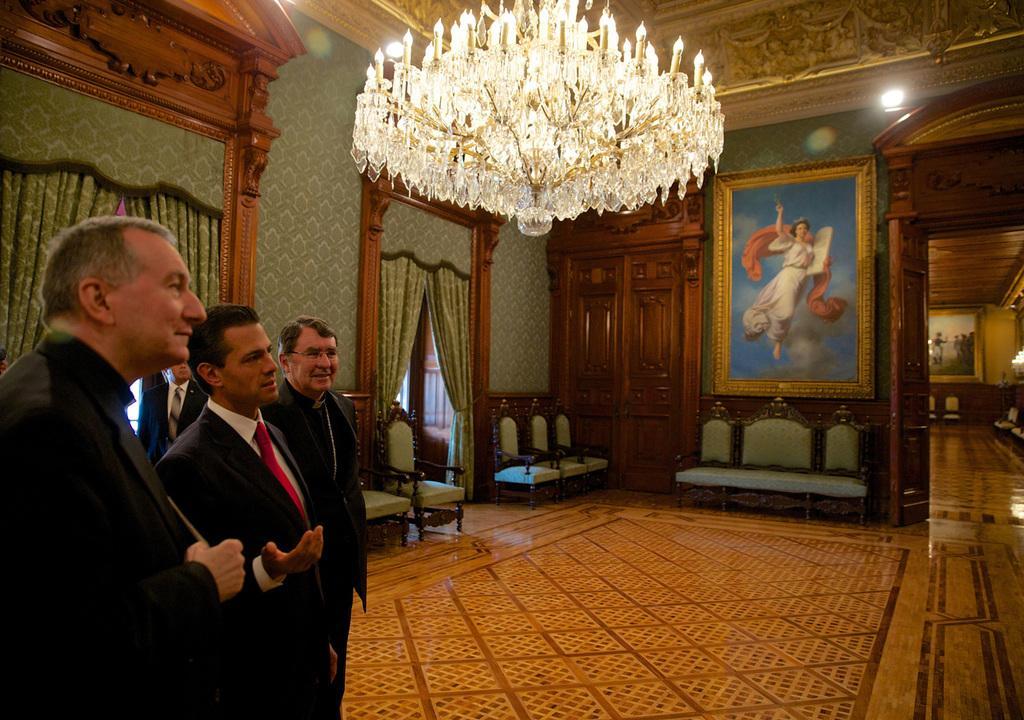Please provide a concise description of this image. In this picture there are three persons who are wearing suit. On the top there is a chandelier. Here we can see photo frame near to the door. In the background we can chairs, tables, carpet, door cloth near to the door. 